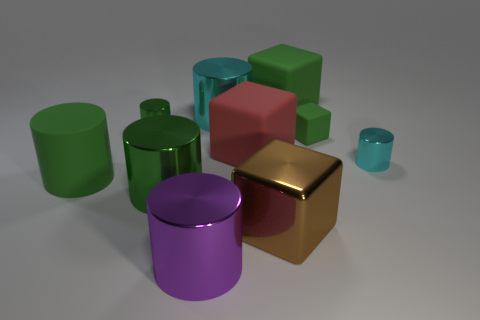Are there any other things that have the same size as the brown object?
Your answer should be compact. Yes. There is a purple shiny object; what shape is it?
Make the answer very short. Cylinder. There is a cylinder that is to the right of the large brown metal cube; what is its material?
Provide a short and direct response. Metal. What is the size of the green metallic object that is behind the rubber cylinder that is in front of the small matte thing that is right of the big brown metallic cube?
Give a very brief answer. Small. Are the green cylinder behind the red rubber thing and the small cylinder that is in front of the red object made of the same material?
Provide a short and direct response. Yes. How many other things are there of the same color as the matte cylinder?
Provide a succinct answer. 4. How many objects are rubber objects that are in front of the small green rubber cube or shiny cylinders that are left of the large green matte block?
Give a very brief answer. 6. There is a cube in front of the green matte object in front of the small cyan thing; what size is it?
Give a very brief answer. Large. How big is the red block?
Your answer should be compact. Large. There is a matte thing that is in front of the tiny cyan shiny thing; is its color the same as the small metal thing that is right of the tiny green cube?
Your answer should be very brief. No. 